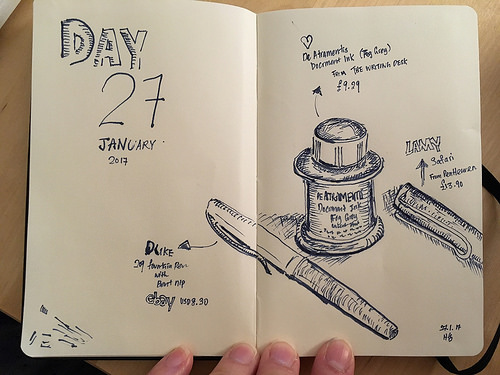<image>
Can you confirm if the pen is to the right of the ink well? No. The pen is not to the right of the ink well. The horizontal positioning shows a different relationship. 